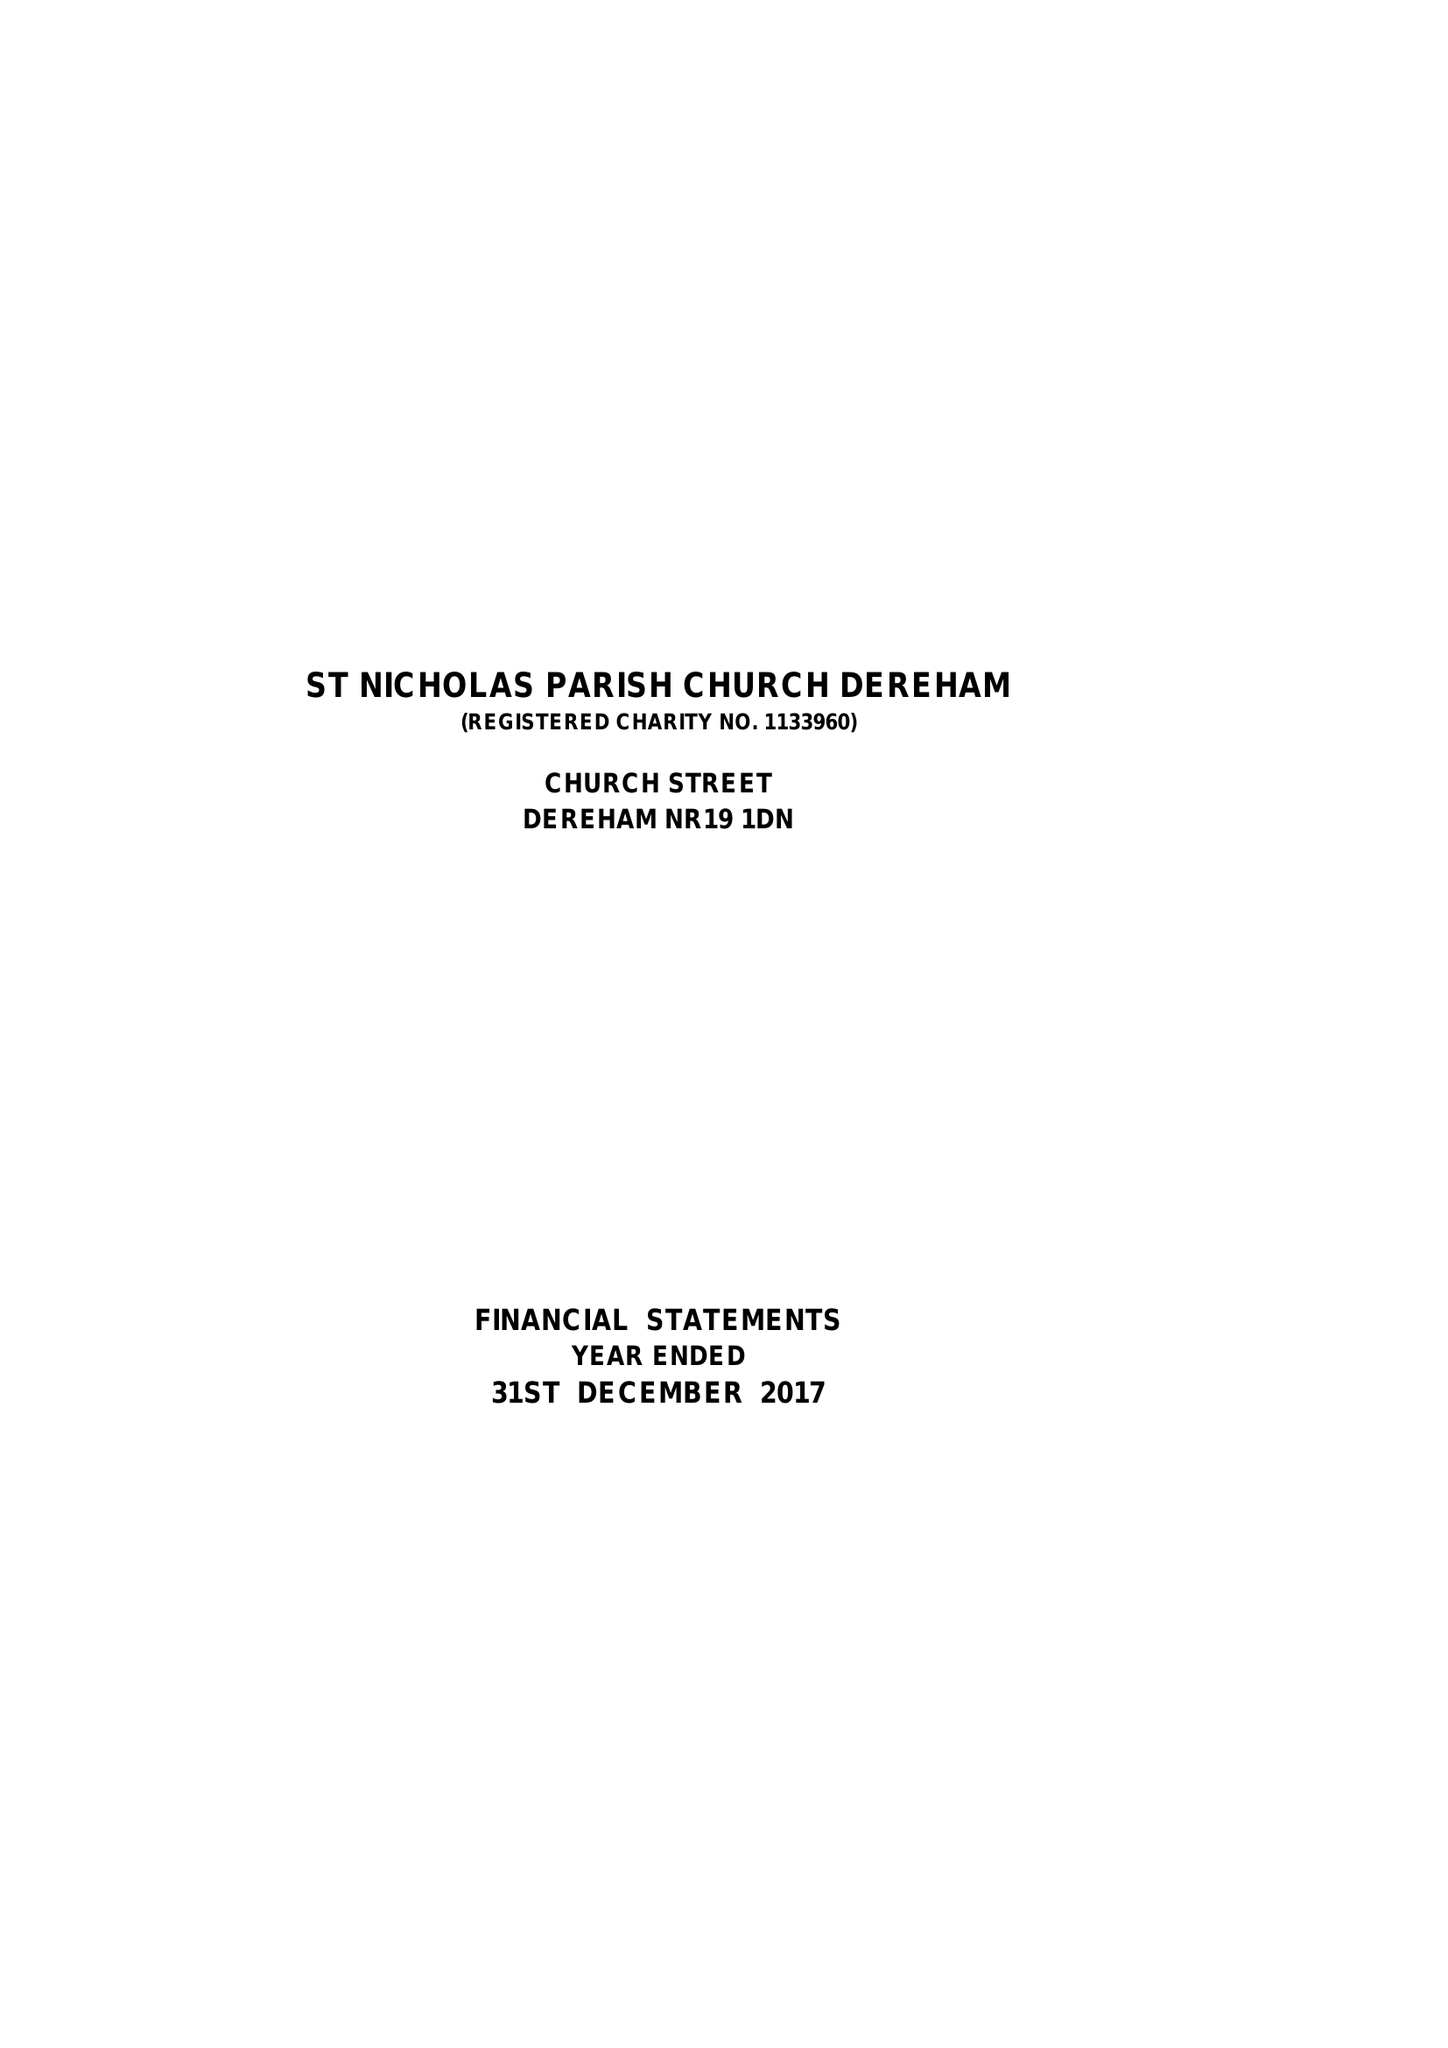What is the value for the spending_annually_in_british_pounds?
Answer the question using a single word or phrase. 106590.00 